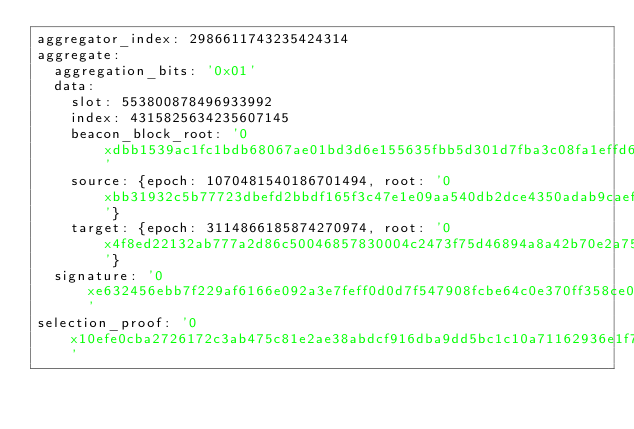<code> <loc_0><loc_0><loc_500><loc_500><_YAML_>aggregator_index: 2986611743235424314
aggregate:
  aggregation_bits: '0x01'
  data:
    slot: 553800878496933992
    index: 4315825634235607145
    beacon_block_root: '0xdbb1539ac1fc1bdb68067ae01bd3d6e155635fbb5d301d7fba3c08fa1effd64e'
    source: {epoch: 1070481540186701494, root: '0xbb31932c5b77723dbefd2bbdf165f3c47e1e09aa540db2dce4350adab9caefc8'}
    target: {epoch: 3114866185874270974, root: '0x4f8ed22132ab777a2d86c50046857830004c2473f75d46894a8a42b70e2a750f'}
  signature: '0xe632456ebb7f229af6166e092a3e7feff0d0d7f547908fcbe64c0e370ff358ce058973e588f48eb74ea02d1cf9c6e765636630046ac4b6136767fe443b64c5dae046edf6419216815422a28b568bcdd5dfde999b01c525e01fd0f0920af76c66'
selection_proof: '0x10efe0cba2726172c3ab475c81e2ae38abdcf916dba9dd5bc1c10a71162936e1f775b27e743c46f331d13e28e18488593cdbcea9973ce7e37a1f7dbfefda6f730626135a29a4f1ad5f649bb2c5039d5aca9f121202ea5ee811144168c3e9602b'
</code> 